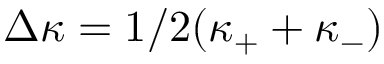Convert formula to latex. <formula><loc_0><loc_0><loc_500><loc_500>\Delta \kappa = 1 / 2 ( \kappa _ { + } + \kappa _ { - } )</formula> 